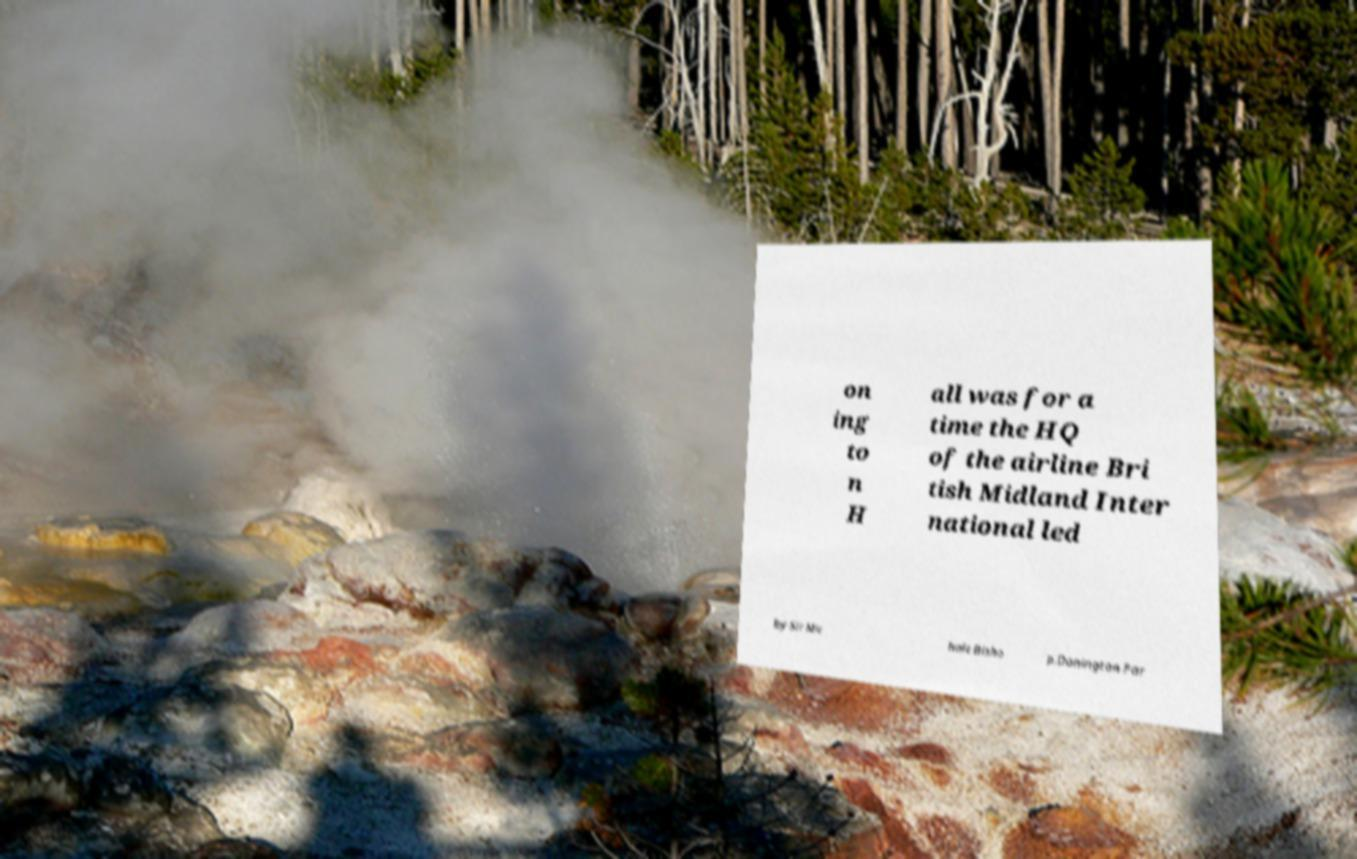Could you assist in decoding the text presented in this image and type it out clearly? on ing to n H all was for a time the HQ of the airline Bri tish Midland Inter national led by Sir Mic hale Bisho p.Donington Par 